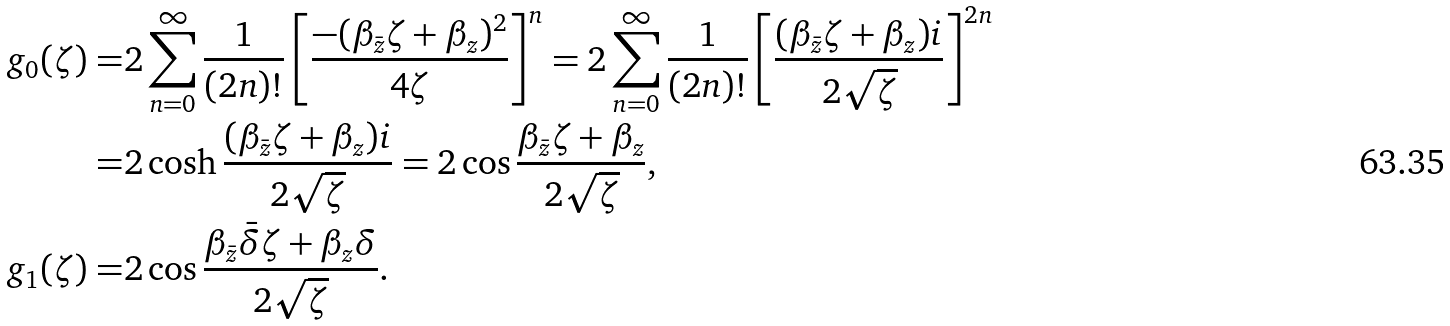<formula> <loc_0><loc_0><loc_500><loc_500>g _ { 0 } ( \zeta ) = & 2 \sum _ { n = 0 } ^ { \infty } \frac { 1 } { ( 2 n ) ! } \left [ \frac { - ( \beta _ { \bar { z } } \zeta + \beta _ { z } ) ^ { 2 } } { 4 \zeta } \right ] ^ { n } = 2 \sum _ { n = 0 } ^ { \infty } \frac { 1 } { ( 2 n ) ! } \left [ \frac { ( \beta _ { \bar { z } } \zeta + \beta _ { z } ) i } { 2 \sqrt { \zeta } } \right ] ^ { 2 n } \\ = & 2 \cosh \frac { ( \beta _ { \bar { z } } \zeta + \beta _ { z } ) i } { 2 \sqrt { \zeta } } = 2 \cos \frac { \beta _ { \bar { z } } \zeta + \beta _ { z } } { 2 \sqrt { \zeta } } , \\ g _ { 1 } ( \zeta ) = & 2 \cos \frac { \beta _ { \bar { z } } \bar { \delta } \zeta + \beta _ { z } \delta } { 2 \sqrt { \zeta } } .</formula> 